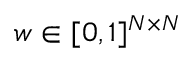Convert formula to latex. <formula><loc_0><loc_0><loc_500><loc_500>w \in [ 0 , 1 ] ^ { N \times N }</formula> 